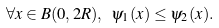<formula> <loc_0><loc_0><loc_500><loc_500>\forall x \in B ( 0 , 2 R ) , \ \psi _ { 1 } ( x ) \leq \psi _ { 2 } ( x ) .</formula> 